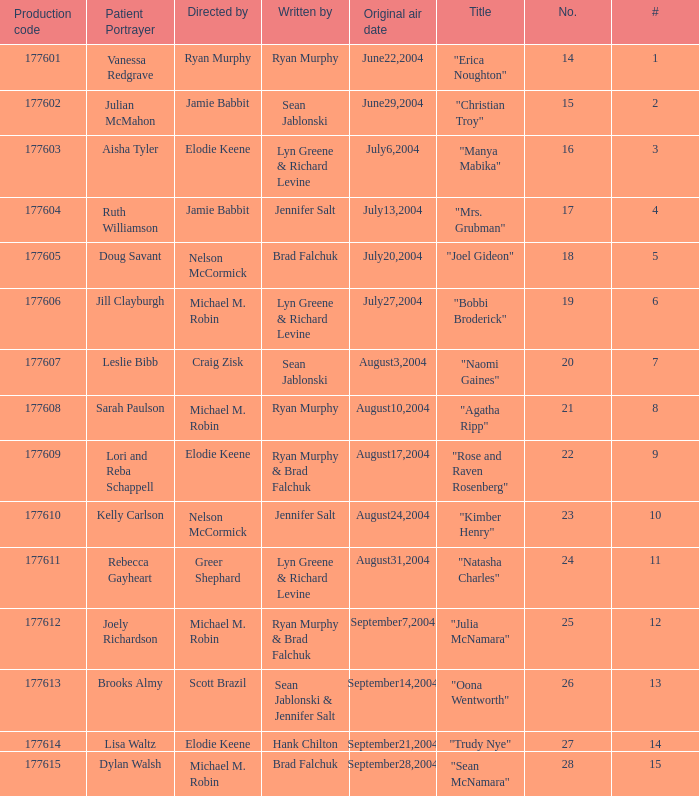How many episodes are numbered 4 in the season? 1.0. 